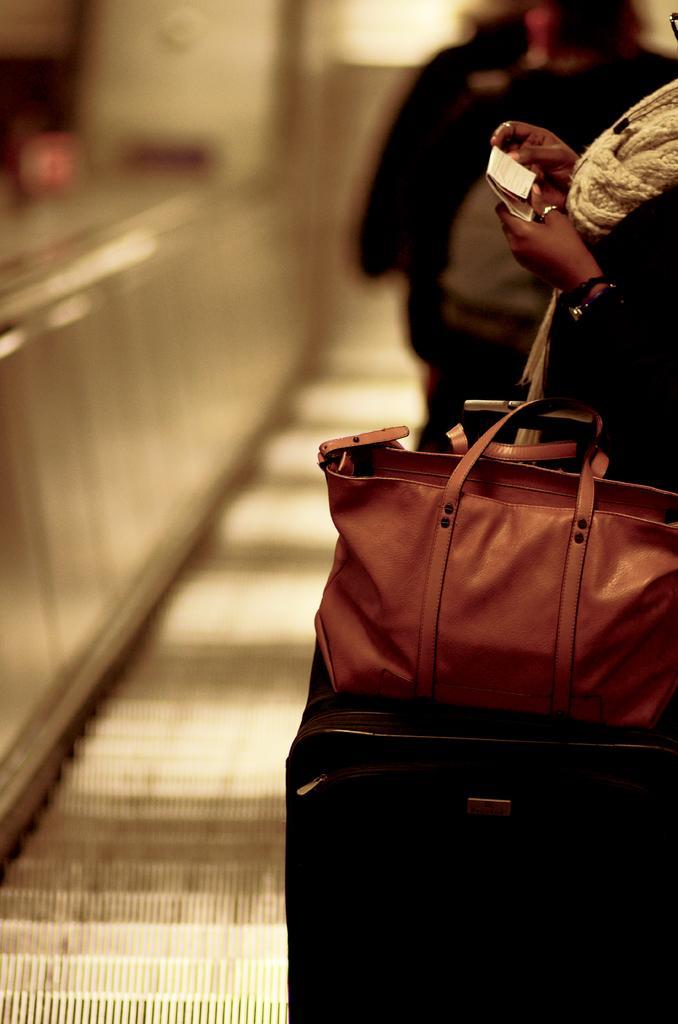Can you describe this image briefly? In this image, on the right, there is a woman she is holding a paper and there is hand bag and trolley bag. In the background there is a person. 